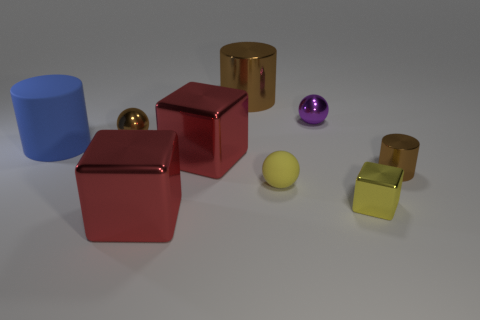Does the small matte thing have the same color as the big metal cylinder?
Make the answer very short. No. Is there any other thing that has the same shape as the yellow matte object?
Provide a short and direct response. Yes. Are there fewer blue cylinders than red objects?
Your answer should be compact. Yes. What is the color of the large metal cylinder on the left side of the brown metal cylinder on the right side of the tiny yellow block?
Offer a terse response. Brown. There is a large red block in front of the brown object that is right of the yellow object behind the yellow shiny cube; what is its material?
Your answer should be compact. Metal. Does the red shiny object that is in front of the matte ball have the same size as the blue matte thing?
Make the answer very short. Yes. What material is the large cylinder that is to the right of the blue rubber object?
Your answer should be compact. Metal. Is the number of yellow shiny cubes greater than the number of small metal spheres?
Your answer should be very brief. No. How many things are big blue matte cylinders in front of the purple shiny thing or gray metallic cylinders?
Offer a terse response. 1. There is a rubber thing in front of the large blue thing; how many small yellow objects are on the left side of it?
Offer a very short reply. 0. 